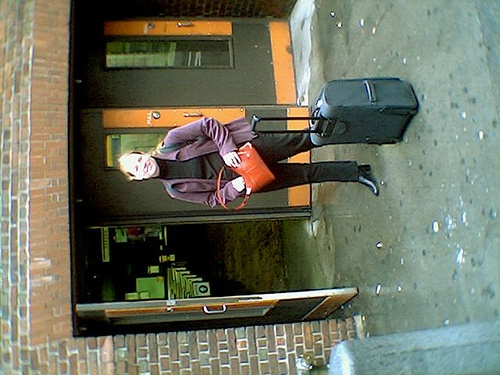Describe the objects in this image and their specific colors. I can see people in olive, black, gray, white, and teal tones, suitcase in olive, black, teal, and gray tones, and handbag in olive, red, salmon, black, and maroon tones in this image. 